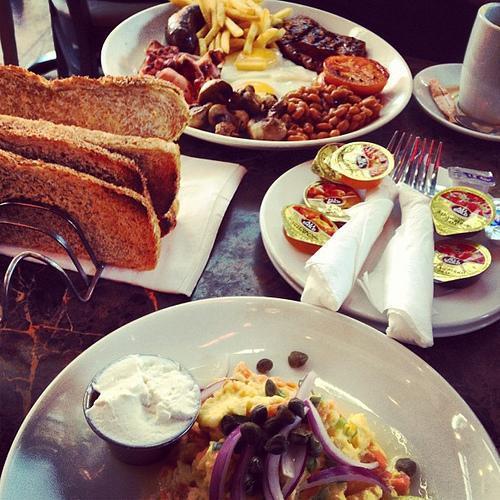How many dinner plates are there?
Give a very brief answer. 2. How many sealed condiment packets are visible?
Give a very brief answer. 8. 